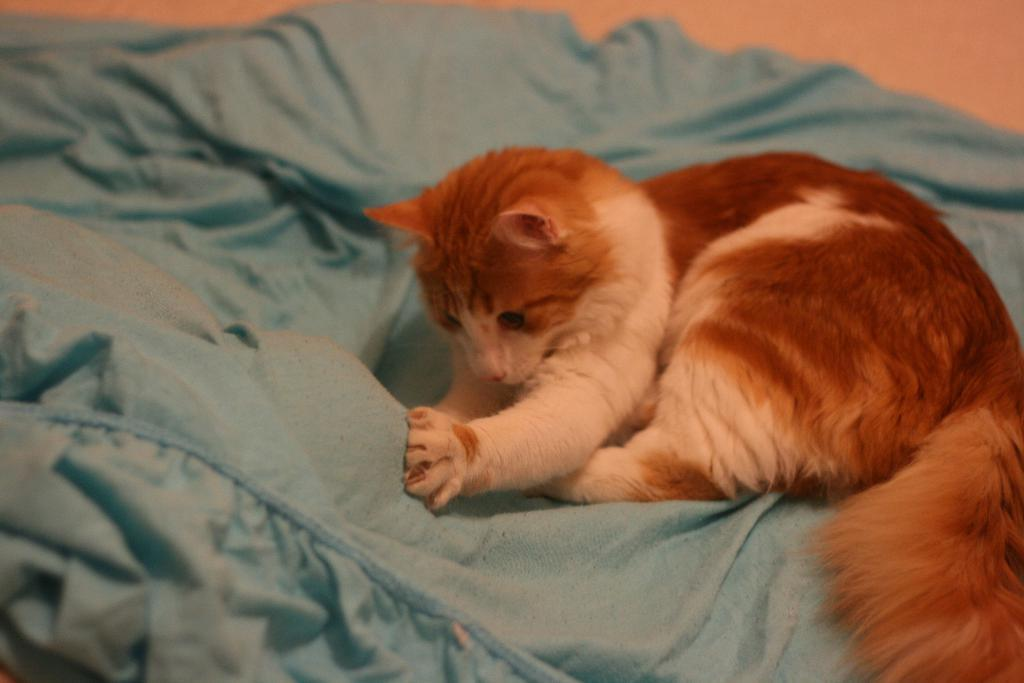What type of animal is present in the image? There is a brown and white cat in the image. What is the cat doing in the image? The cat is playing with a blue color bed sheet. What type of pan is visible in the image? There is no pan present in the image. What color are the cattle in the image? There are no cattle present in the image. What type of orange object can be seen in the image? There is no orange object present in the image. 